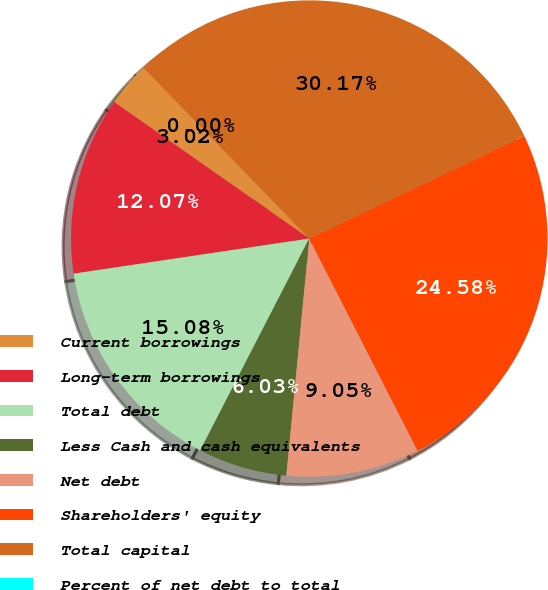Convert chart. <chart><loc_0><loc_0><loc_500><loc_500><pie_chart><fcel>Current borrowings<fcel>Long-term borrowings<fcel>Total debt<fcel>Less Cash and cash equivalents<fcel>Net debt<fcel>Shareholders' equity<fcel>Total capital<fcel>Percent of net debt to total<nl><fcel>3.02%<fcel>12.07%<fcel>15.08%<fcel>6.03%<fcel>9.05%<fcel>24.58%<fcel>30.17%<fcel>0.0%<nl></chart> 